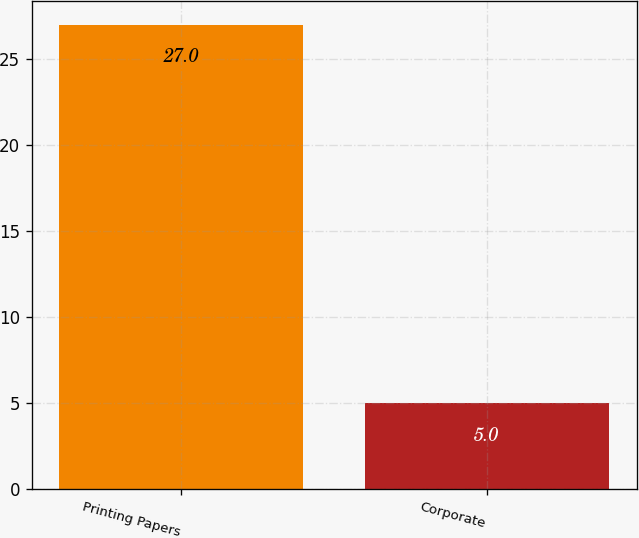Convert chart to OTSL. <chart><loc_0><loc_0><loc_500><loc_500><bar_chart><fcel>Printing Papers<fcel>Corporate<nl><fcel>27<fcel>5<nl></chart> 